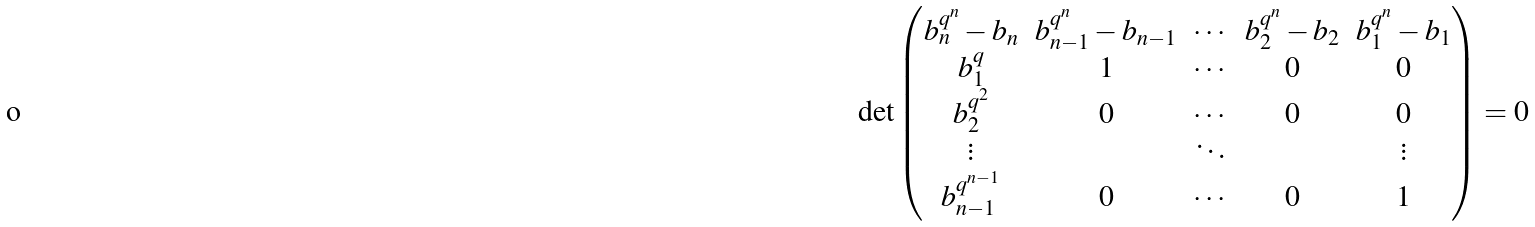<formula> <loc_0><loc_0><loc_500><loc_500>\det \begin{pmatrix} b _ { n } ^ { q ^ { n } } - b _ { n } & b _ { n - 1 } ^ { q ^ { n } } - b _ { n - 1 } & \cdots & b _ { 2 } ^ { q ^ { n } } - b _ { 2 } & b _ { 1 } ^ { q ^ { n } } - b _ { 1 } \\ b _ { 1 } ^ { q } & 1 & \cdots & 0 & 0 \\ b _ { 2 } ^ { q ^ { 2 } } & 0 & \cdots & 0 & 0 \\ \vdots & & \ddots & & \vdots \\ b _ { n - 1 } ^ { q ^ { n - 1 } } & 0 & \cdots & 0 & 1 \end{pmatrix} = 0</formula> 